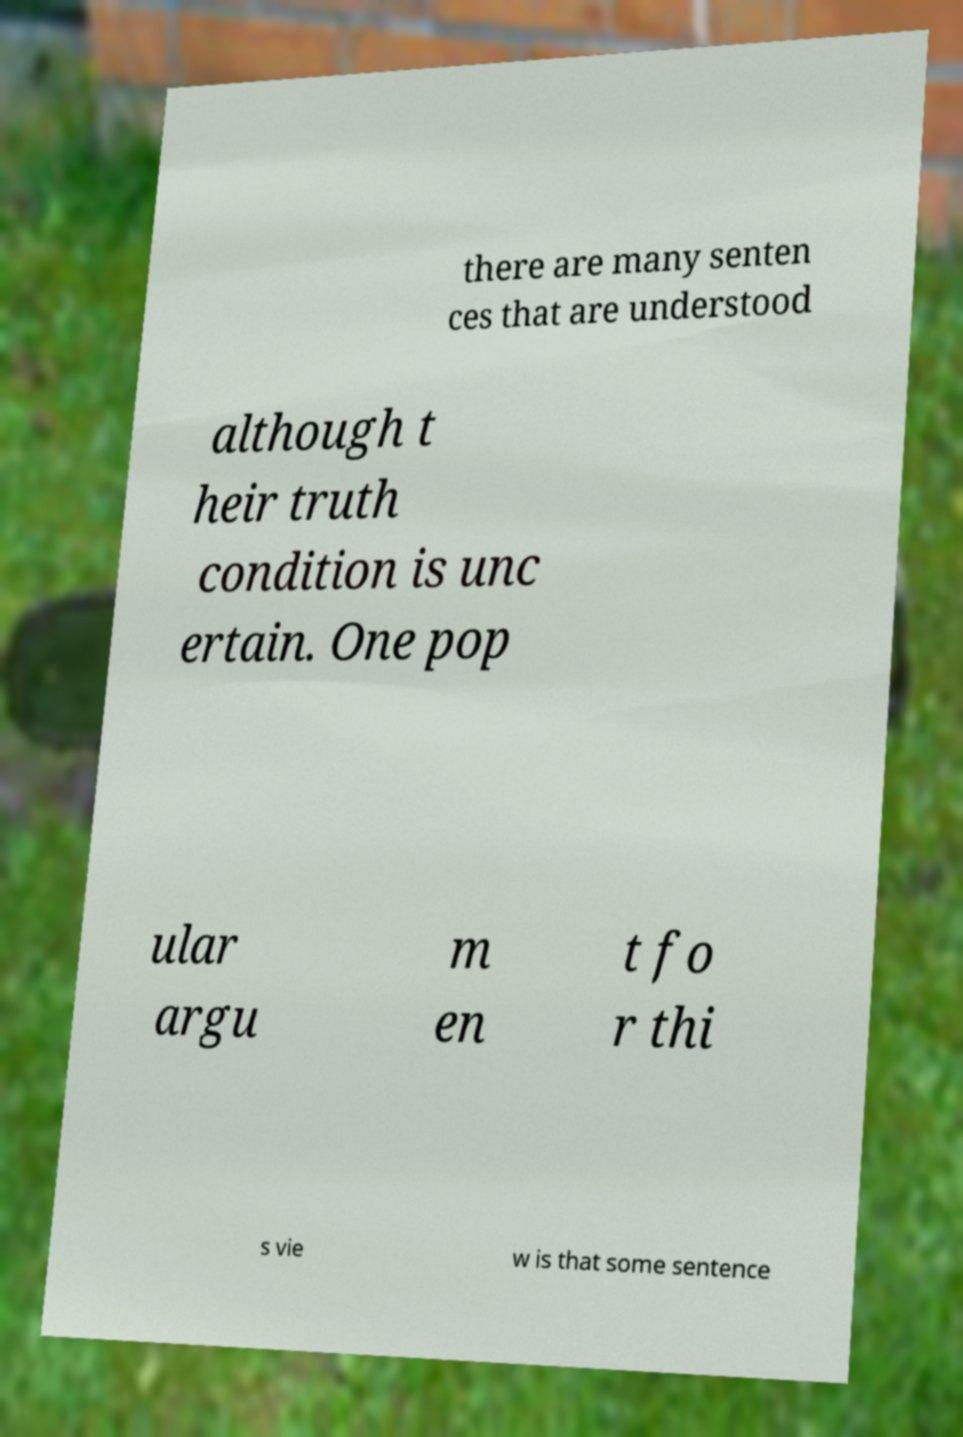Please identify and transcribe the text found in this image. there are many senten ces that are understood although t heir truth condition is unc ertain. One pop ular argu m en t fo r thi s vie w is that some sentence 